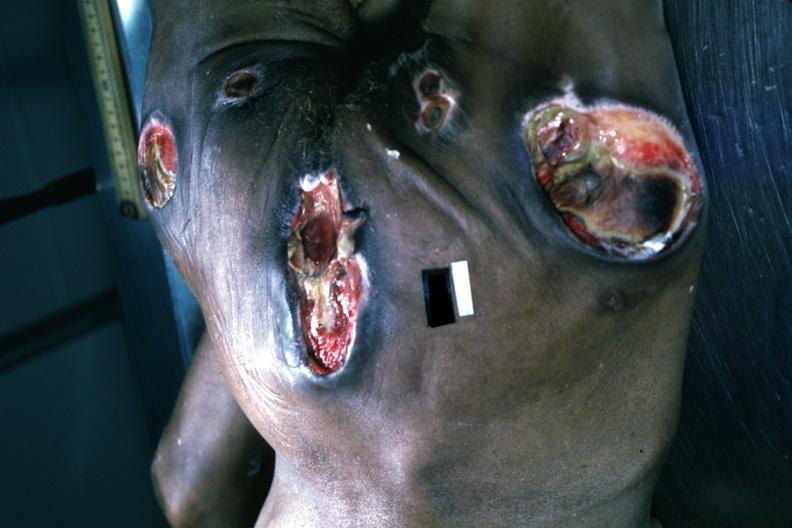what is present?
Answer the question using a single word or phrase. Decubitus ulcer 